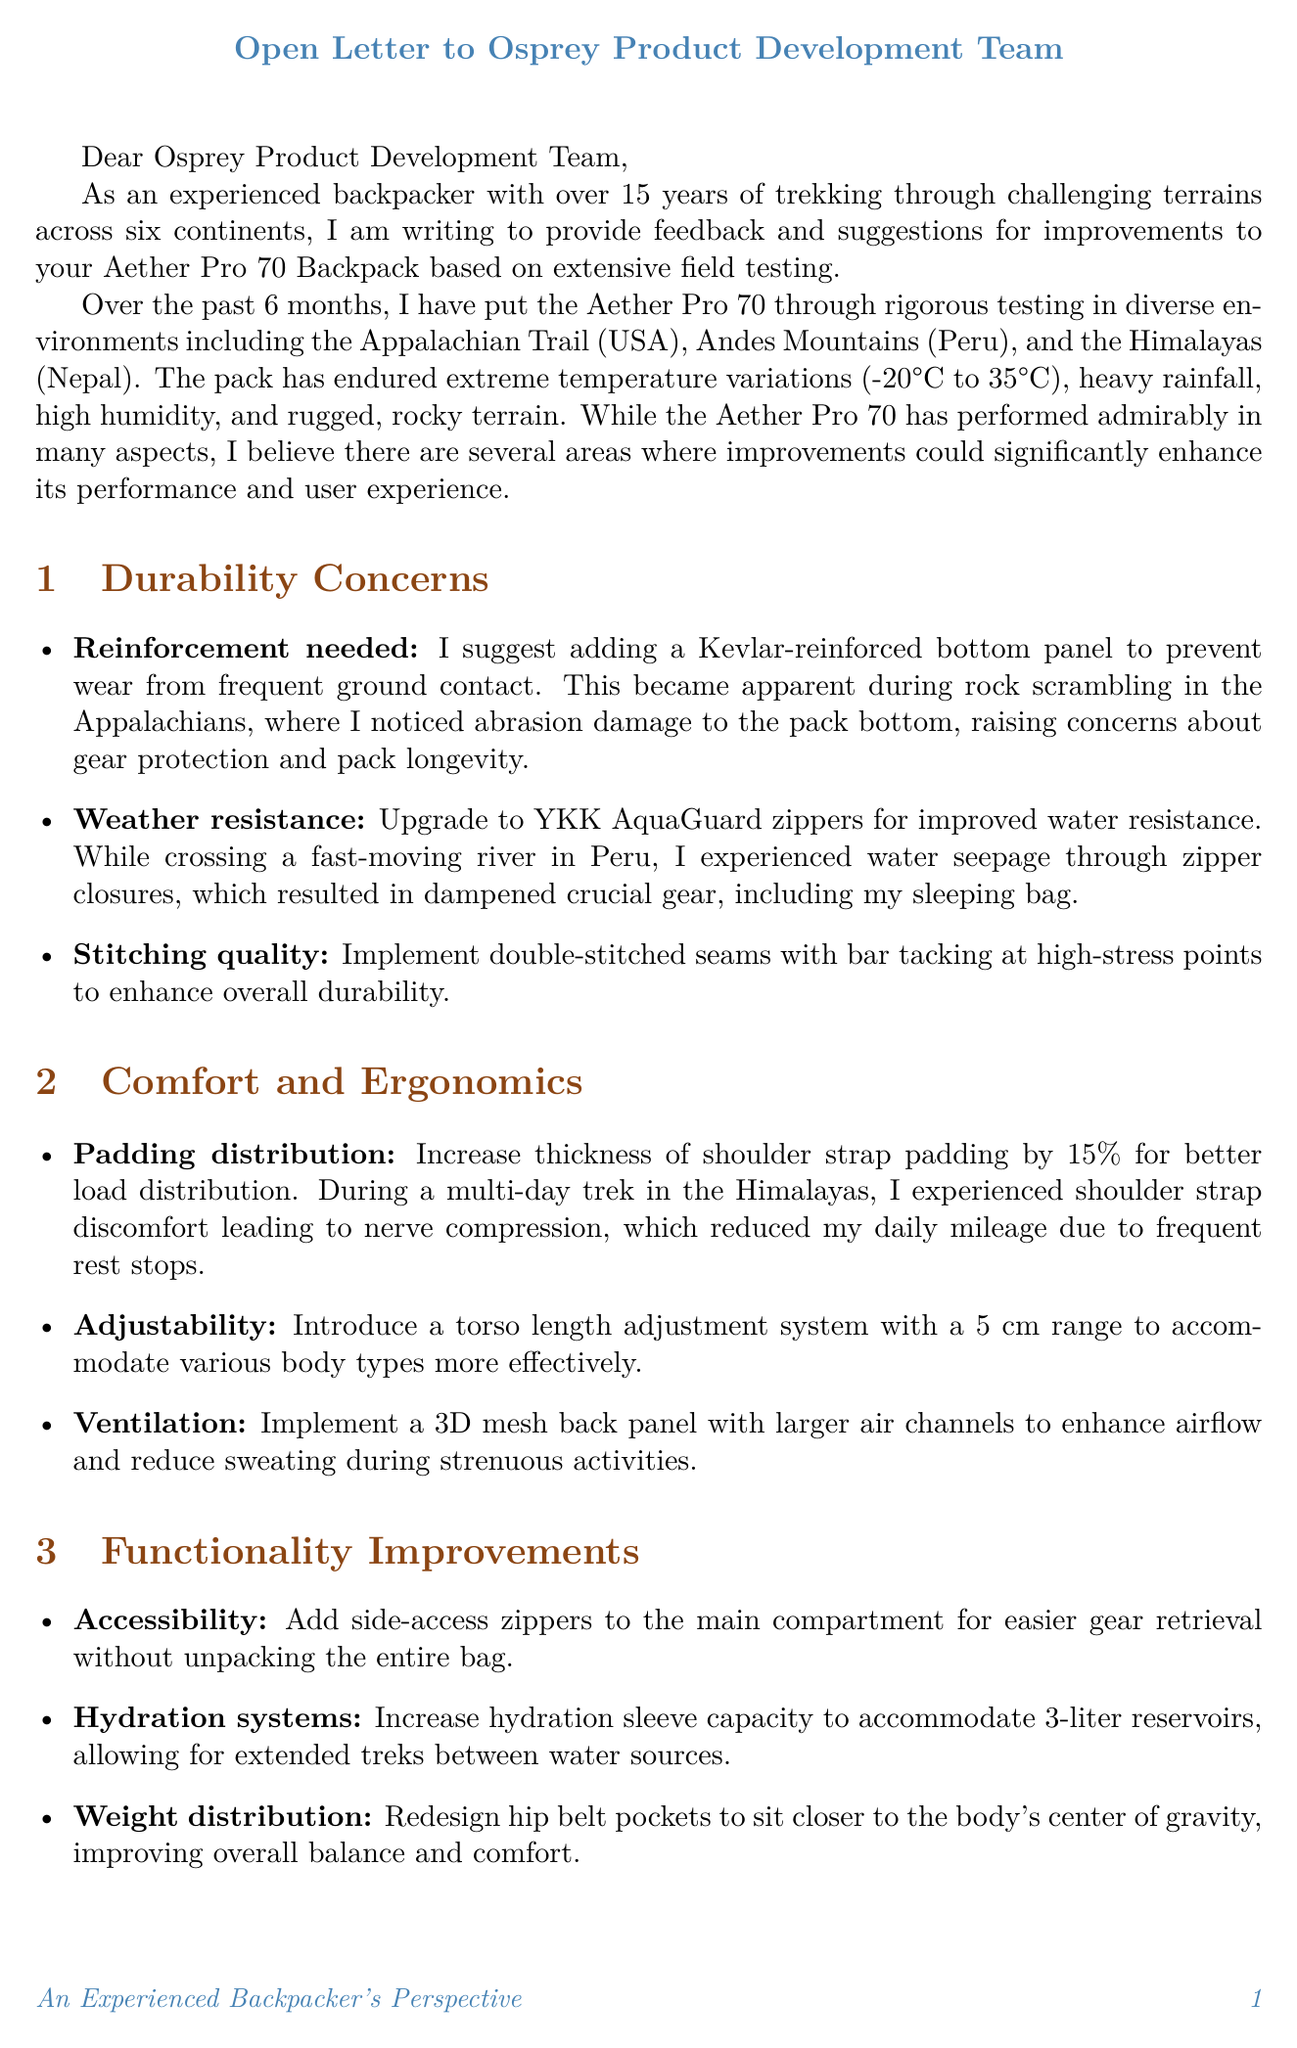What is the name of the backpack discussed in the letter? The letter mentions the Aether Pro 70 Backpack as the product being discussed.
Answer: Aether Pro 70 Backpack How many years of backpacking experience does the author have? The author states they have over 15 years of experience in backpacking across various terrains.
Answer: 15 years What is one suggested durability improvement for the backpack? The author suggests adding a Kevlar-reinforced bottom panel to enhance durability, particularly against wear from ground contact.
Answer: Kevlar-reinforced bottom panel Which location was not included in the field testing? The letter refers to three locations where testing occurred, and one not mentioned is the Rocky Mountains.
Answer: Rocky Mountains What specific issue did the author face when crossing a river? The author experienced water seepage through zipper closures, resulting in dampened gear.
Answer: Water seepage through zipper closures What type of feature does the author suggest for improving comfort? The author suggests increasing the thickness of shoulder strap padding for better load distribution during long treks.
Answer: Increase thickness of shoulder strap padding What innovative material does the author recommend incorporating? The letter suggests incorporating CORDURA ECO fabric made from recycled plastic bottles for sustainability.
Answer: CORDURA ECO fabric What specific adjustment system is recommended for better fit? The author recommends introducing a torso length adjustment system with a 5 cm range to accommodate different body types.
Answer: Torso length adjustment system with 5 cm range 